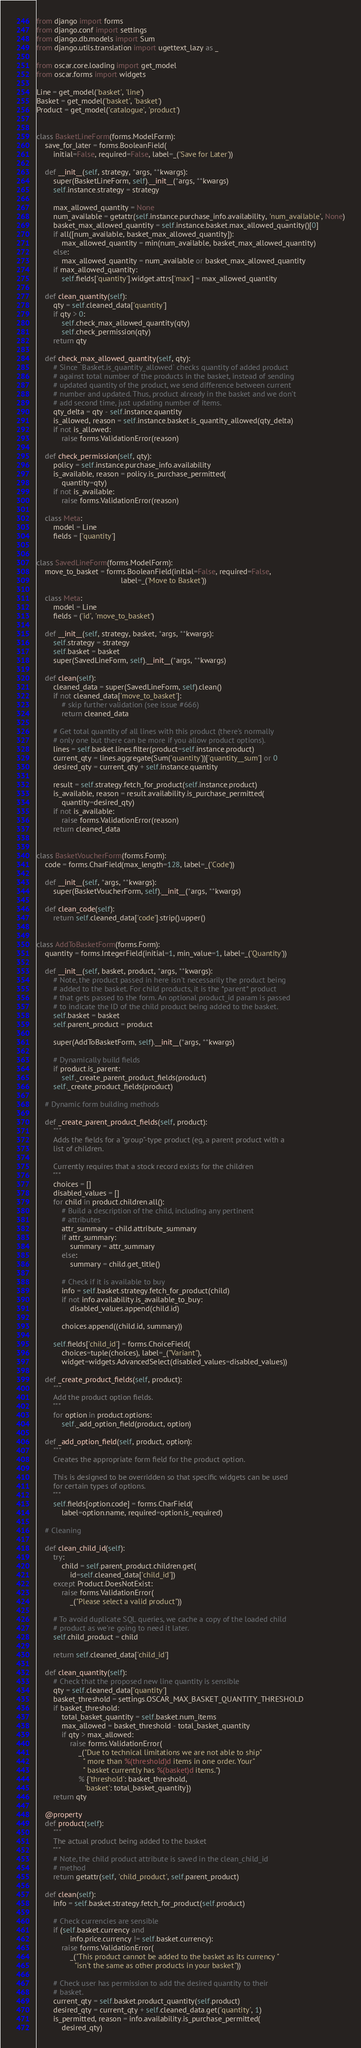<code> <loc_0><loc_0><loc_500><loc_500><_Python_>from django import forms
from django.conf import settings
from django.db.models import Sum
from django.utils.translation import ugettext_lazy as _

from oscar.core.loading import get_model
from oscar.forms import widgets

Line = get_model('basket', 'line')
Basket = get_model('basket', 'basket')
Product = get_model('catalogue', 'product')


class BasketLineForm(forms.ModelForm):
    save_for_later = forms.BooleanField(
        initial=False, required=False, label=_('Save for Later'))

    def __init__(self, strategy, *args, **kwargs):
        super(BasketLineForm, self).__init__(*args, **kwargs)
        self.instance.strategy = strategy

        max_allowed_quantity = None
        num_available = getattr(self.instance.purchase_info.availability, 'num_available', None)
        basket_max_allowed_quantity = self.instance.basket.max_allowed_quantity()[0]
        if all([num_available, basket_max_allowed_quantity]):
            max_allowed_quantity = min(num_available, basket_max_allowed_quantity)
        else:
            max_allowed_quantity = num_available or basket_max_allowed_quantity
        if max_allowed_quantity:
            self.fields['quantity'].widget.attrs['max'] = max_allowed_quantity

    def clean_quantity(self):
        qty = self.cleaned_data['quantity']
        if qty > 0:
            self.check_max_allowed_quantity(qty)
            self.check_permission(qty)
        return qty

    def check_max_allowed_quantity(self, qty):
        # Since `Basket.is_quantity_allowed` checks quantity of added product
        # against total number of the products in the basket, instead of sending
        # updated quantity of the product, we send difference between current
        # number and updated. Thus, product already in the basket and we don't
        # add second time, just updating number of items.
        qty_delta = qty - self.instance.quantity
        is_allowed, reason = self.instance.basket.is_quantity_allowed(qty_delta)
        if not is_allowed:
            raise forms.ValidationError(reason)

    def check_permission(self, qty):
        policy = self.instance.purchase_info.availability
        is_available, reason = policy.is_purchase_permitted(
            quantity=qty)
        if not is_available:
            raise forms.ValidationError(reason)

    class Meta:
        model = Line
        fields = ['quantity']


class SavedLineForm(forms.ModelForm):
    move_to_basket = forms.BooleanField(initial=False, required=False,
                                        label=_('Move to Basket'))

    class Meta:
        model = Line
        fields = ('id', 'move_to_basket')

    def __init__(self, strategy, basket, *args, **kwargs):
        self.strategy = strategy
        self.basket = basket
        super(SavedLineForm, self).__init__(*args, **kwargs)

    def clean(self):
        cleaned_data = super(SavedLineForm, self).clean()
        if not cleaned_data['move_to_basket']:
            # skip further validation (see issue #666)
            return cleaned_data

        # Get total quantity of all lines with this product (there's normally
        # only one but there can be more if you allow product options).
        lines = self.basket.lines.filter(product=self.instance.product)
        current_qty = lines.aggregate(Sum('quantity'))['quantity__sum'] or 0
        desired_qty = current_qty + self.instance.quantity

        result = self.strategy.fetch_for_product(self.instance.product)
        is_available, reason = result.availability.is_purchase_permitted(
            quantity=desired_qty)
        if not is_available:
            raise forms.ValidationError(reason)
        return cleaned_data


class BasketVoucherForm(forms.Form):
    code = forms.CharField(max_length=128, label=_('Code'))

    def __init__(self, *args, **kwargs):
        super(BasketVoucherForm, self).__init__(*args, **kwargs)

    def clean_code(self):
        return self.cleaned_data['code'].strip().upper()


class AddToBasketForm(forms.Form):
    quantity = forms.IntegerField(initial=1, min_value=1, label=_('Quantity'))

    def __init__(self, basket, product, *args, **kwargs):
        # Note, the product passed in here isn't necessarily the product being
        # added to the basket. For child products, it is the *parent* product
        # that gets passed to the form. An optional product_id param is passed
        # to indicate the ID of the child product being added to the basket.
        self.basket = basket
        self.parent_product = product

        super(AddToBasketForm, self).__init__(*args, **kwargs)

        # Dynamically build fields
        if product.is_parent:
            self._create_parent_product_fields(product)
        self._create_product_fields(product)

    # Dynamic form building methods

    def _create_parent_product_fields(self, product):
        """
        Adds the fields for a "group"-type product (eg, a parent product with a
        list of children.

        Currently requires that a stock record exists for the children
        """
        choices = []
        disabled_values = []
        for child in product.children.all():
            # Build a description of the child, including any pertinent
            # attributes
            attr_summary = child.attribute_summary
            if attr_summary:
                summary = attr_summary
            else:
                summary = child.get_title()

            # Check if it is available to buy
            info = self.basket.strategy.fetch_for_product(child)
            if not info.availability.is_available_to_buy:
                disabled_values.append(child.id)

            choices.append((child.id, summary))

        self.fields['child_id'] = forms.ChoiceField(
            choices=tuple(choices), label=_("Variant"),
            widget=widgets.AdvancedSelect(disabled_values=disabled_values))

    def _create_product_fields(self, product):
        """
        Add the product option fields.
        """
        for option in product.options:
            self._add_option_field(product, option)

    def _add_option_field(self, product, option):
        """
        Creates the appropriate form field for the product option.

        This is designed to be overridden so that specific widgets can be used
        for certain types of options.
        """
        self.fields[option.code] = forms.CharField(
            label=option.name, required=option.is_required)

    # Cleaning

    def clean_child_id(self):
        try:
            child = self.parent_product.children.get(
                id=self.cleaned_data['child_id'])
        except Product.DoesNotExist:
            raise forms.ValidationError(
                _("Please select a valid product"))

        # To avoid duplicate SQL queries, we cache a copy of the loaded child
        # product as we're going to need it later.
        self.child_product = child

        return self.cleaned_data['child_id']

    def clean_quantity(self):
        # Check that the proposed new line quantity is sensible
        qty = self.cleaned_data['quantity']
        basket_threshold = settings.OSCAR_MAX_BASKET_QUANTITY_THRESHOLD
        if basket_threshold:
            total_basket_quantity = self.basket.num_items
            max_allowed = basket_threshold - total_basket_quantity
            if qty > max_allowed:
                raise forms.ValidationError(
                    _("Due to technical limitations we are not able to ship"
                      " more than %(threshold)d items in one order. Your"
                      " basket currently has %(basket)d items.")
                    % {'threshold': basket_threshold,
                       'basket': total_basket_quantity})
        return qty

    @property
    def product(self):
        """
        The actual product being added to the basket
        """
        # Note, the child product attribute is saved in the clean_child_id
        # method
        return getattr(self, 'child_product', self.parent_product)

    def clean(self):
        info = self.basket.strategy.fetch_for_product(self.product)

        # Check currencies are sensible
        if (self.basket.currency and
                info.price.currency != self.basket.currency):
            raise forms.ValidationError(
                _("This product cannot be added to the basket as its currency "
                  "isn't the same as other products in your basket"))

        # Check user has permission to add the desired quantity to their
        # basket.
        current_qty = self.basket.product_quantity(self.product)
        desired_qty = current_qty + self.cleaned_data.get('quantity', 1)
        is_permitted, reason = info.availability.is_purchase_permitted(
            desired_qty)</code> 